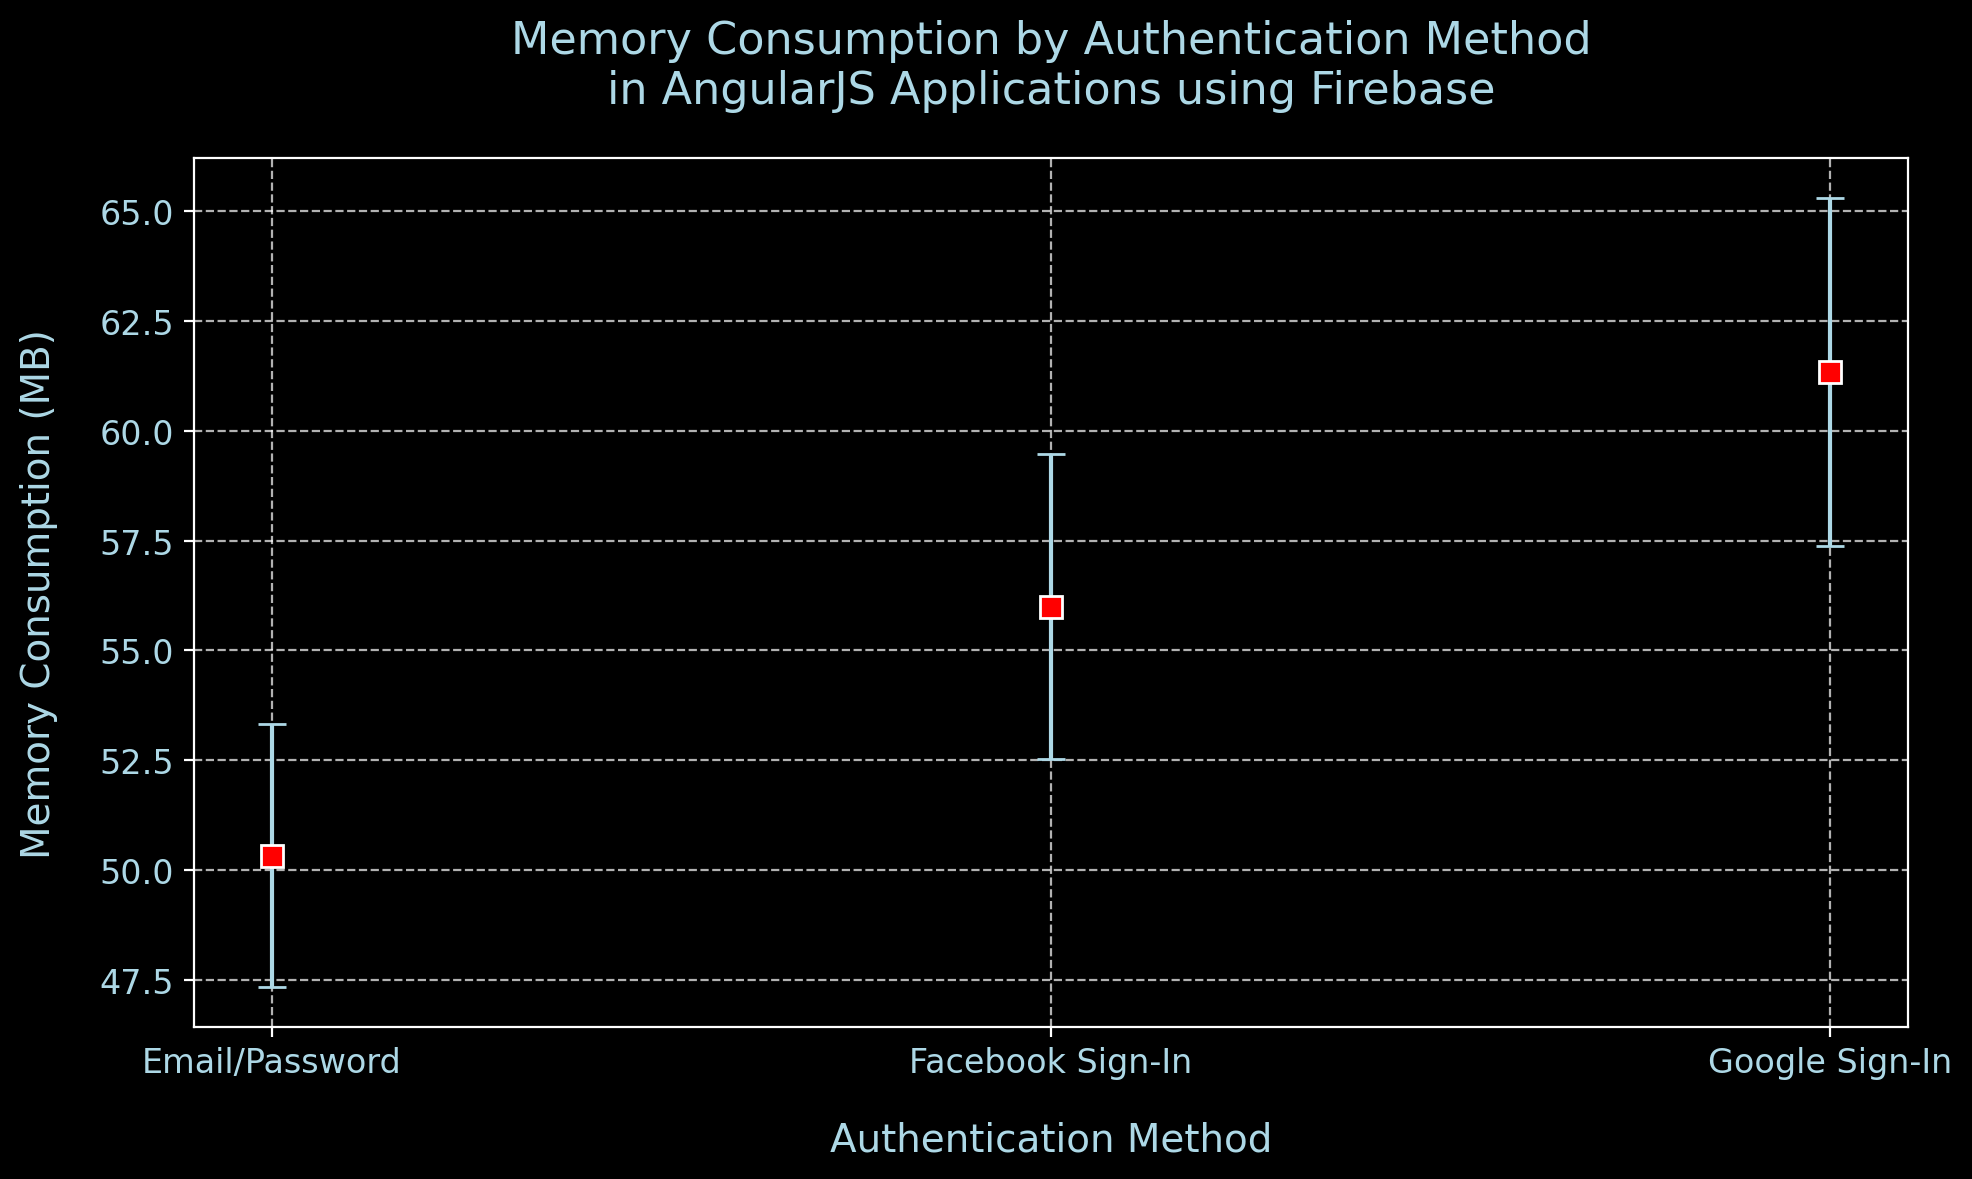What is the average memory consumption for the Email/Password authentication method? To find the average, sum the memory consumption values for the Email/Password method (50 + 52 + 49 = 151) and divide by the number of data points (3), so the average is 151/3.
Answer: 50.33 Which authentication method has the highest average memory consumption? By comparing the mean memory consumption values of all methods, the Google Sign-In method has the highest average memory consumption of 61.33 MB.
Answer: Google Sign-In Which authentication method shows the smallest standard error in memory consumption? By comparing the mean standard errors, the Email/Password method has the smallest mean standard error of 3.0 MB.
Answer: Email/Password What is the range of memory consumption for the Facebook Sign-In method? The range is the difference between the highest and lowest memory consumption values for Facebook Sign-In (57 - 55 = 2 MB).
Answer: 2 By how much does the average memory consumption of Google Sign-In exceed that of the Email/Password method? Subtract the average memory consumption of Email/Password (50.33 MB) from Google Sign-In (61.33 MB) to find the difference, which is 61.33 - 50.33.
Answer: 11 MB What color represents the marker for memory consumption values in the plot? The plot uses red color for the markers representing memory consumption values for different authentication methods.
Answer: Red How does the average memory consumption for Facebook Sign-In compare to the mean memory consumption for Email/Password? The average for Facebook Sign-In is 56 MB, which is higher than the average for Email/Password at 50.33 MB.
Answer: Higher What is the total combined memory consumption for all data points using Email/Password authentication? Add the values for Email/Password (50 + 52 + 49 = 151 MB).
Answer: 151 MB Based on the error bars, which authentication method has the most variability in memory consumption? The Google Sign-In method has the highest mean standard error of 3.97 MB, indicating the most variability.
Answer: Google Sign-In Which authentication method has a mean memory consumption closest to 55 MB? The Facebook Sign-In method has a mean memory consumption of 56 MB, which is the closest to 55 MB among the methods shown.
Answer: Facebook Sign-In 